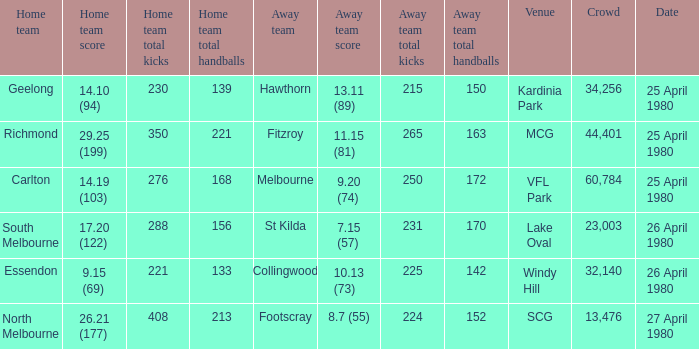What was the lowest crowd size at MCG? 44401.0. 